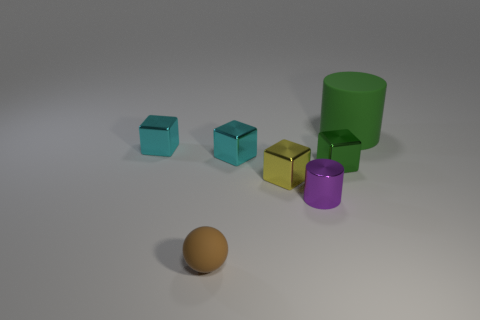Subtract all cyan cylinders. Subtract all blue cubes. How many cylinders are left? 2 Add 2 tiny metallic objects. How many objects exist? 9 Subtract all spheres. How many objects are left? 6 Add 6 purple cylinders. How many purple cylinders exist? 7 Subtract 0 purple balls. How many objects are left? 7 Subtract all tiny cyan objects. Subtract all brown rubber objects. How many objects are left? 4 Add 3 small cyan shiny objects. How many small cyan shiny objects are left? 5 